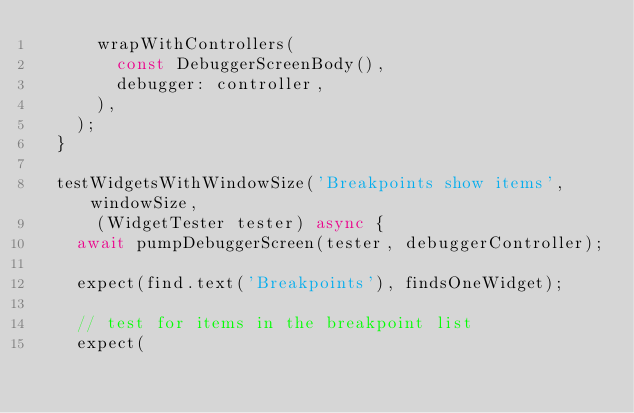Convert code to text. <code><loc_0><loc_0><loc_500><loc_500><_Dart_>      wrapWithControllers(
        const DebuggerScreenBody(),
        debugger: controller,
      ),
    );
  }

  testWidgetsWithWindowSize('Breakpoints show items', windowSize,
      (WidgetTester tester) async {
    await pumpDebuggerScreen(tester, debuggerController);

    expect(find.text('Breakpoints'), findsOneWidget);

    // test for items in the breakpoint list
    expect(</code> 